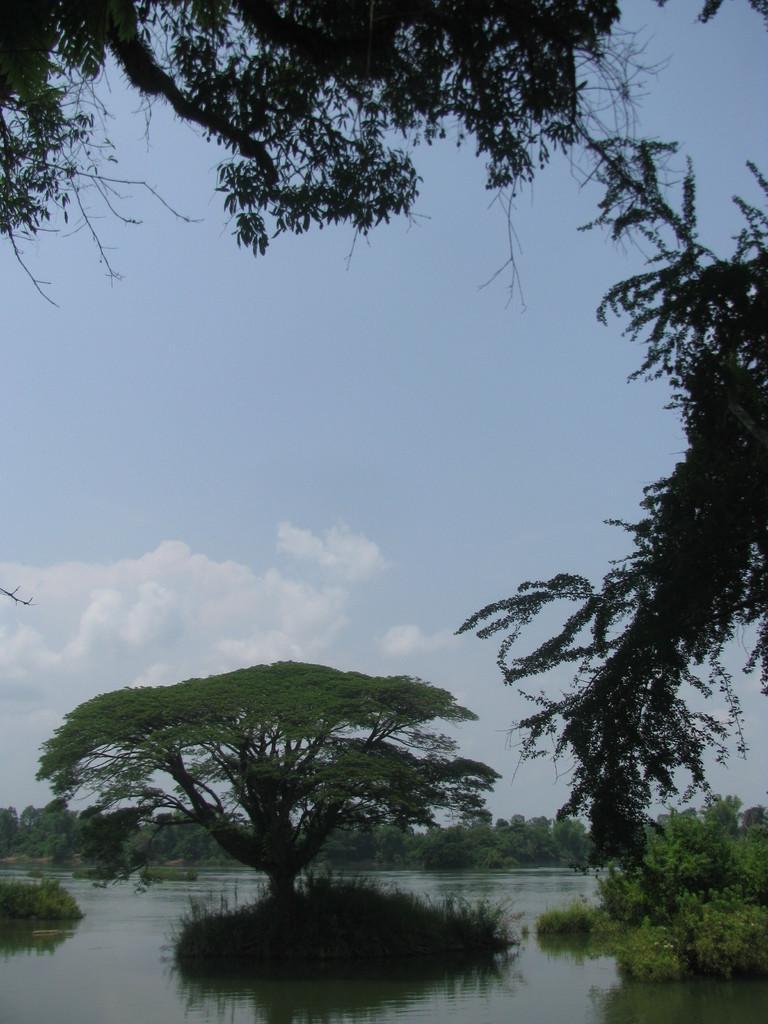Could you give a brief overview of what you see in this image? In this image I can see few trees on the water. In the back I can see many trees, clouds and the blue sky. 